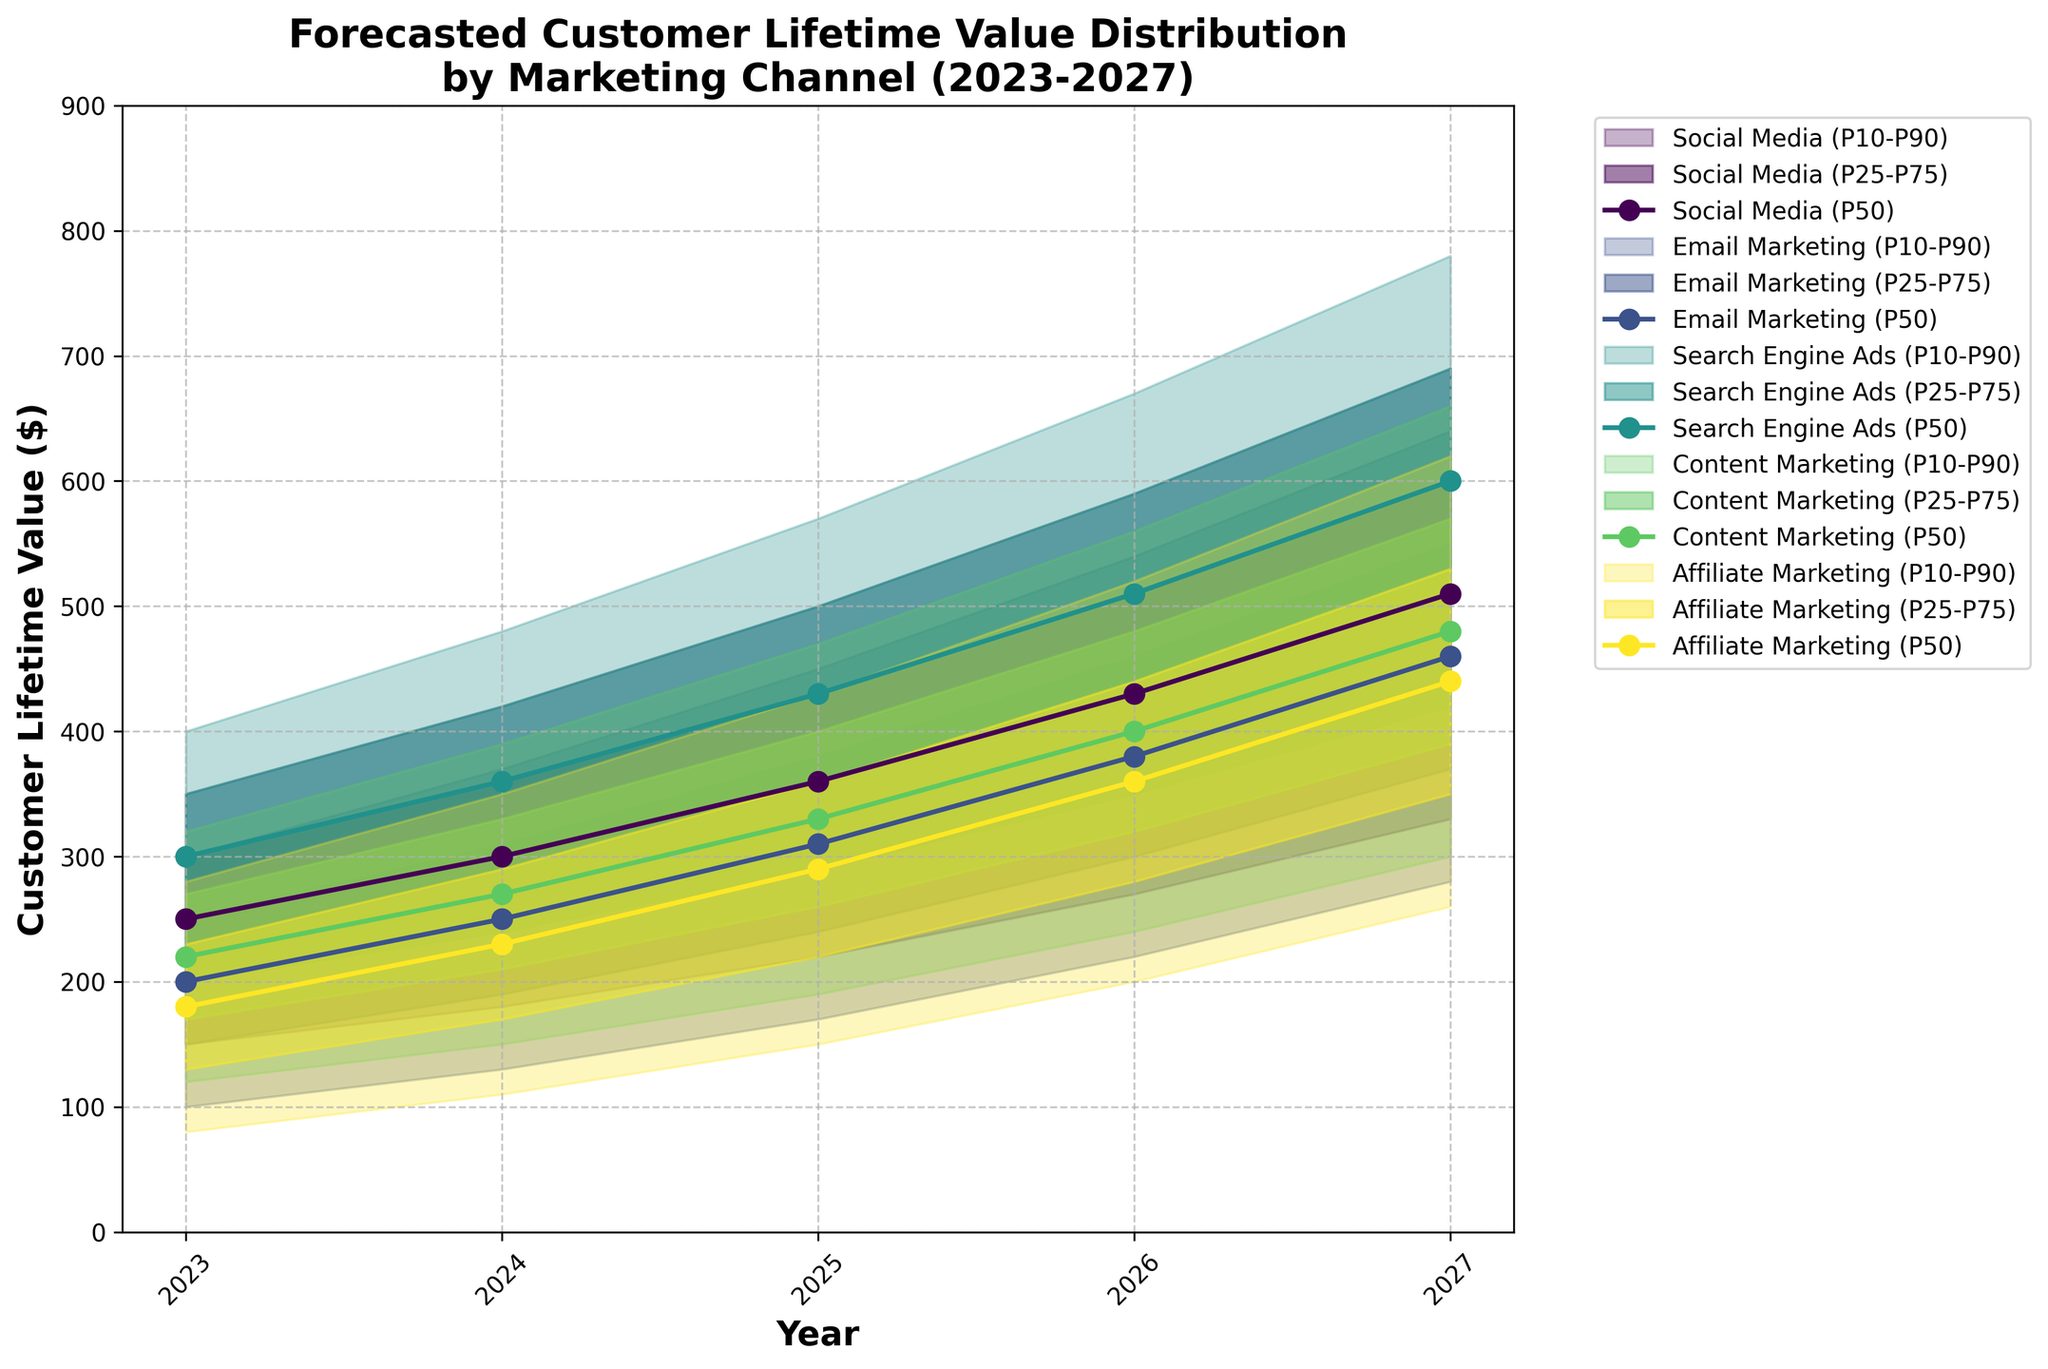What does the title of the chart say? The title is at the top of the chart and typically summarizes the content it represents. In this case, the title is 'Forecasted Customer Lifetime Value Distribution by Marketing Channel (2023-2027).'
Answer: Forecasted Customer Lifetime Value Distribution by Marketing Channel (2023-2027) How many marketing channels are being compared in the figure? By inspecting the legend on the right side of the chart, you can count the number of marketing channels listed.
Answer: 5 What are the years shown on the x-axis? The x-axis typically represents time in this chart. The tick marks along the x-axis show the years included in the forecast.
Answer: 2023-2027 Which marketing channel has the highest median customer lifetime value in 2027? The median value corresponds to the P50 prediction line. By looking at the P50 lines, the line for 'Search Engine Ads' reaches the highest point on the y-axis in 2027.
Answer: Search Engine Ads What is the range (difference between P90 and P10) for the Social Media channel in 2025? The range can be found by subtracting the P10 from the P90 value for the given year and channel. For Social Media in 2025, P90 is 500 and P10 is 220. Hence, the range is 500 - 220.
Answer: 280 Which channel exhibits the widest uncertainty in 2026? Uncertainty is indicated by the spread between the P10 and P90 lines. By comparing the spreads in 2026, 'Search Engine Ads' has the widest range.
Answer: Search Engine Ads In which year does Email Marketing see its P75 value reach 550? To determine this, follow the P75 line for Email Marketing across the different years until it reaches 550. For Email Marketing, this happens in 2027.
Answer: 2027 What is the difference between the P50 value of Content Marketing and Affiliate Marketing in 2024? The P50 value represents the median for each channel. For Content Marketing, P50 in 2024 is 270, and for Affiliate Marketing, it is 230. The difference is 270 - 230.
Answer: 40 Compare the growth in median customer lifetime value for Social Media from 2023 to 2027. The median value or P50 line for Social Media in 2023 is 250 and in 2027 is 510. The growth is the difference between these two values: 510 - 250.
Answer: 260 